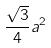Convert formula to latex. <formula><loc_0><loc_0><loc_500><loc_500>\frac { \sqrt { 3 } } { 4 } a ^ { 2 }</formula> 